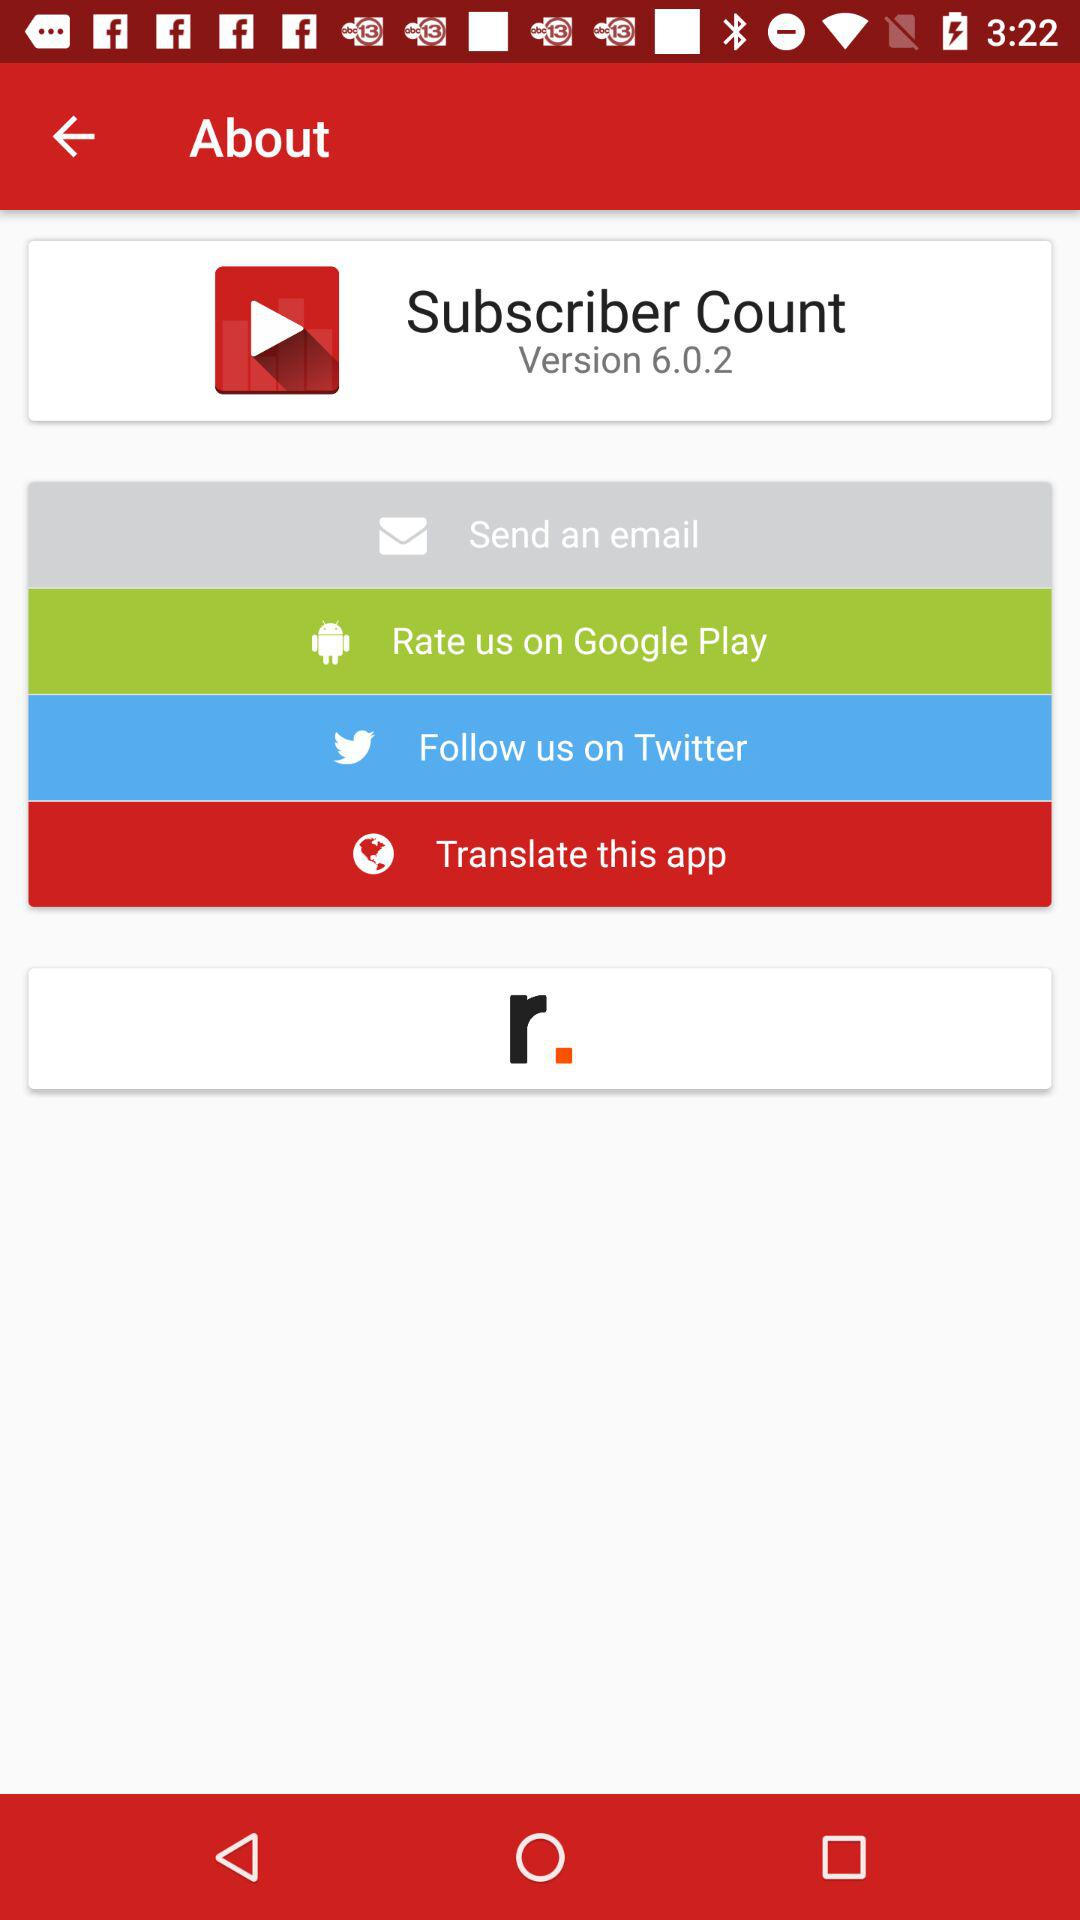What is the version of the app?
Answer the question using a single word or phrase. 6.0.2 